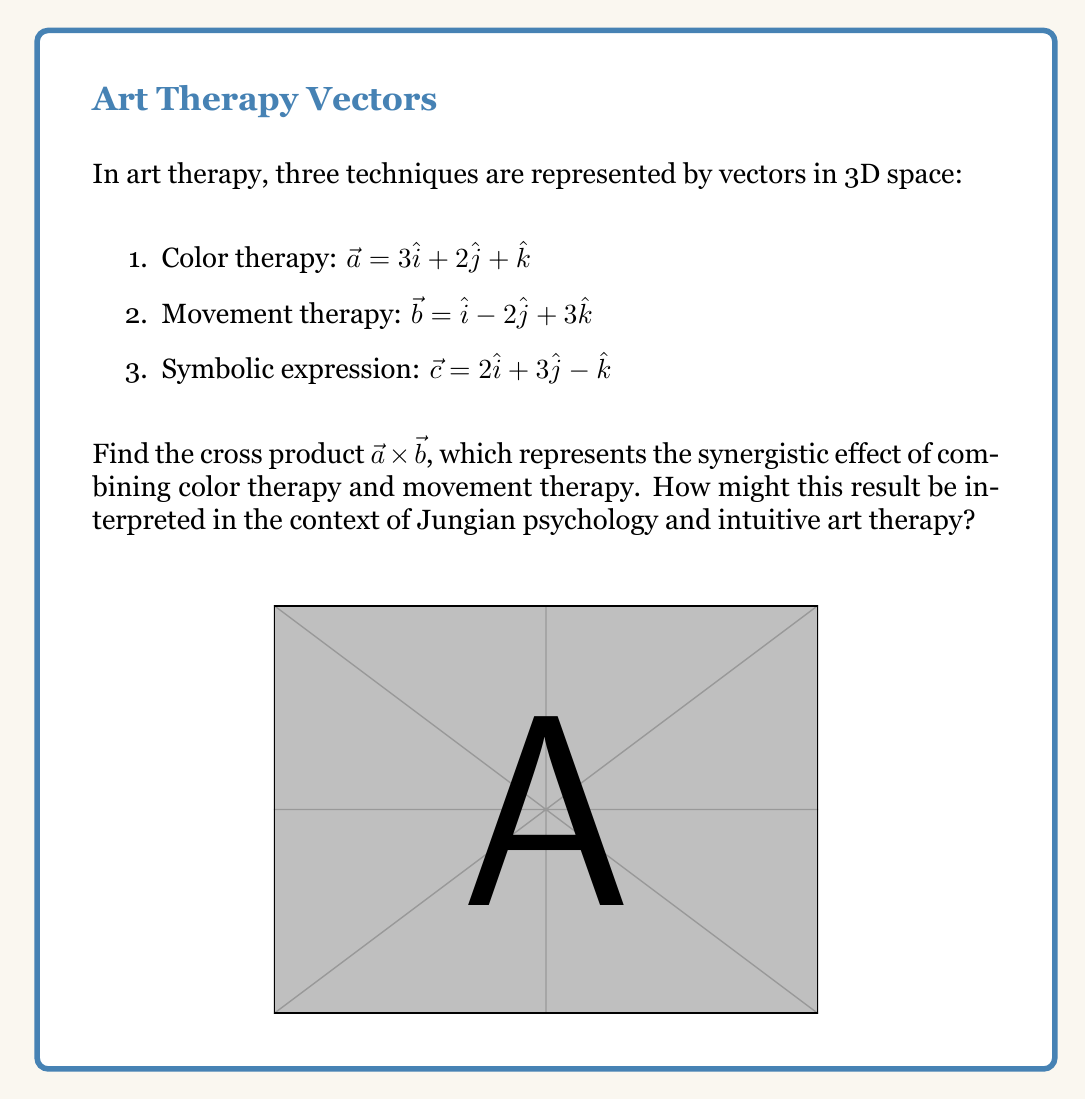Solve this math problem. To find the cross product $\vec{a} \times \vec{b}$, we use the formula:

$$\vec{a} \times \vec{b} = (a_y b_z - a_z b_y)\hat{i} + (a_z b_x - a_x b_z)\hat{j} + (a_x b_y - a_y b_x)\hat{k}$$

Where:
$\vec{a} = 3\hat{i} + 2\hat{j} + \hat{k}$
$\vec{b} = \hat{i} - 2\hat{j} + 3\hat{k}$

Step 1: Calculate $(a_y b_z - a_z b_y)$
$(2 \cdot 3 - 1 \cdot (-2)) = 6 + 2 = 8$

Step 2: Calculate $(a_z b_x - a_x b_z)$
$(1 \cdot 1 - 3 \cdot 3) = 1 - 9 = -8$

Step 3: Calculate $(a_x b_y - a_y b_x)$
$(3 \cdot (-2) - 2 \cdot 1) = -6 - 2 = -8$

Step 4: Combine the results
$\vec{a} \times \vec{b} = 8\hat{i} - 8\hat{j} - 8\hat{k}$

Interpretation: In Jungian psychology, this cross product could represent the emergence of new insights or therapeutic approaches that arise from the integration of color and movement therapies. The balanced nature of the result (all components having the same magnitude) might suggest a holistic and well-rounded therapeutic effect, aligning with Jung's concept of psychic wholeness.
Answer: $\vec{a} \times \vec{b} = 8\hat{i} - 8\hat{j} - 8\hat{k}$ 